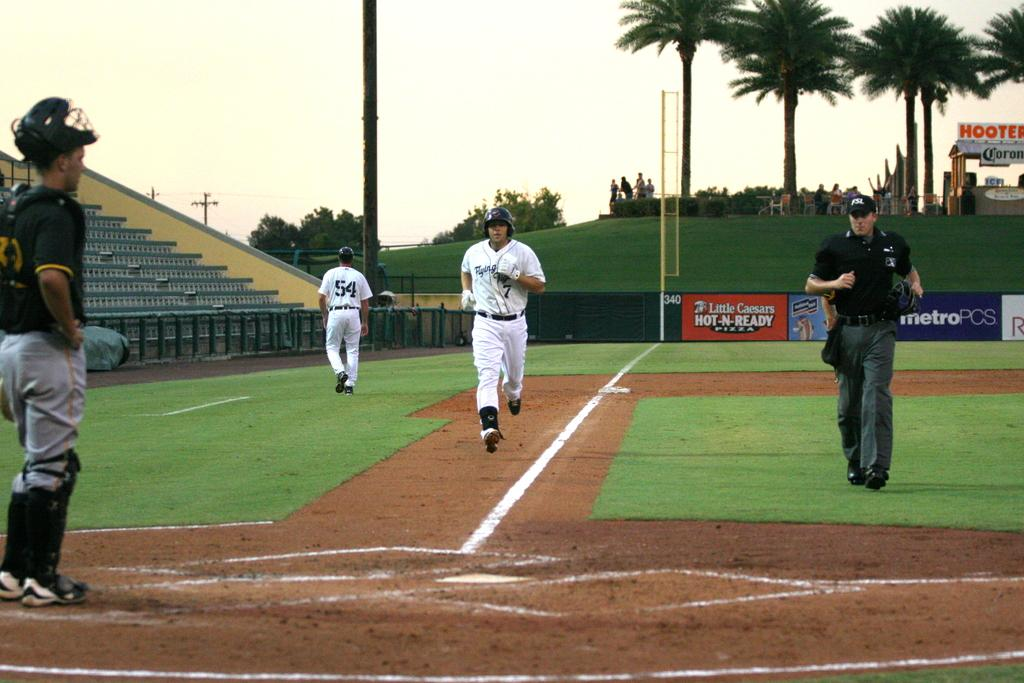<image>
Write a terse but informative summary of the picture. Baseball player number 7 is running to home plate with a Little Caesars Hot-N-Ready sign on the fence in the background. 